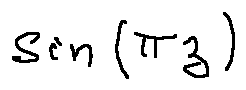Convert formula to latex. <formula><loc_0><loc_0><loc_500><loc_500>\sin ( \pi z )</formula> 